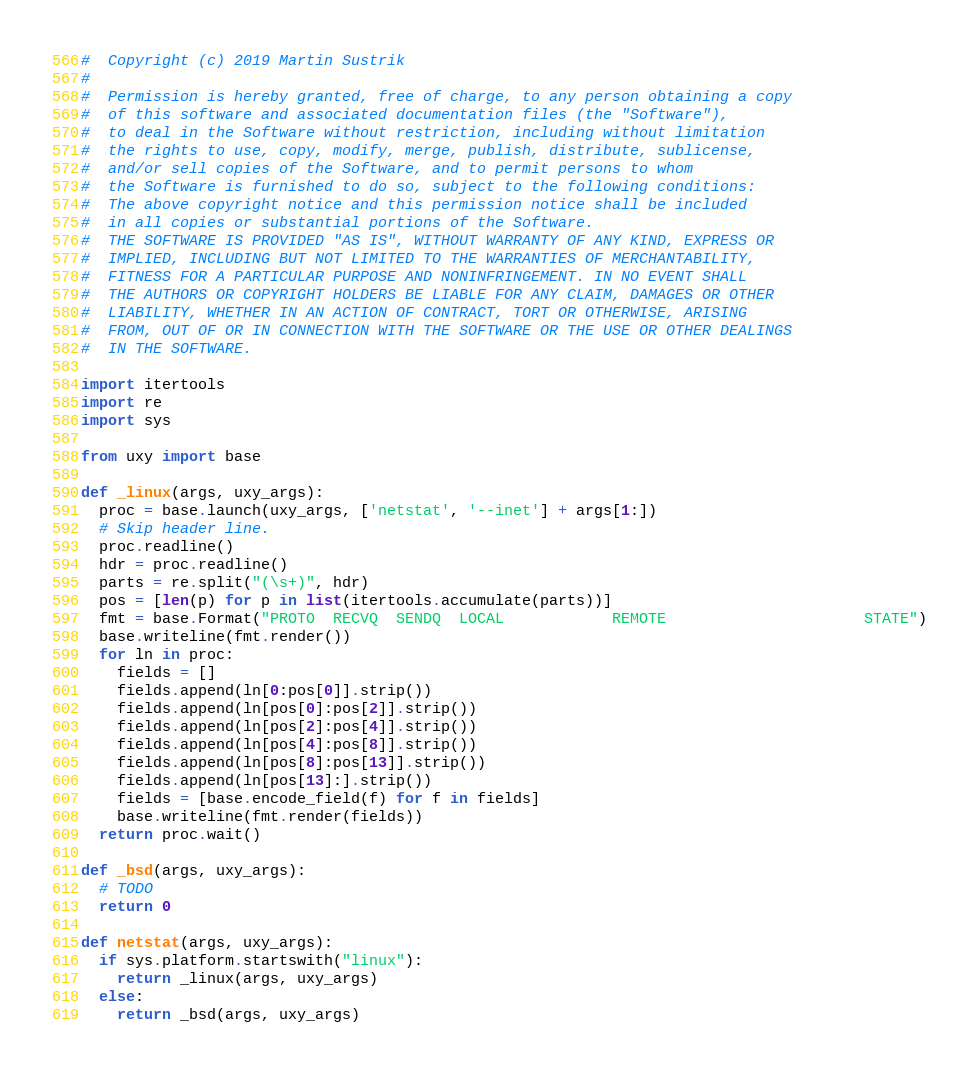<code> <loc_0><loc_0><loc_500><loc_500><_Python_>#  Copyright (c) 2019 Martin Sustrik
#
#  Permission is hereby granted, free of charge, to any person obtaining a copy
#  of this software and associated documentation files (the "Software"),
#  to deal in the Software without restriction, including without limitation
#  the rights to use, copy, modify, merge, publish, distribute, sublicense,
#  and/or sell copies of the Software, and to permit persons to whom
#  the Software is furnished to do so, subject to the following conditions:
#  The above copyright notice and this permission notice shall be included
#  in all copies or substantial portions of the Software.
#  THE SOFTWARE IS PROVIDED "AS IS", WITHOUT WARRANTY OF ANY KIND, EXPRESS OR
#  IMPLIED, INCLUDING BUT NOT LIMITED TO THE WARRANTIES OF MERCHANTABILITY,
#  FITNESS FOR A PARTICULAR PURPOSE AND NONINFRINGEMENT. IN NO EVENT SHALL
#  THE AUTHORS OR COPYRIGHT HOLDERS BE LIABLE FOR ANY CLAIM, DAMAGES OR OTHER
#  LIABILITY, WHETHER IN AN ACTION OF CONTRACT, TORT OR OTHERWISE, ARISING
#  FROM, OUT OF OR IN CONNECTION WITH THE SOFTWARE OR THE USE OR OTHER DEALINGS
#  IN THE SOFTWARE.

import itertools
import re
import sys

from uxy import base

def _linux(args, uxy_args):
  proc = base.launch(uxy_args, ['netstat', '--inet'] + args[1:])
  # Skip header line.
  proc.readline()
  hdr = proc.readline()
  parts = re.split("(\s+)", hdr)
  pos = [len(p) for p in list(itertools.accumulate(parts))]
  fmt = base.Format("PROTO  RECVQ  SENDQ  LOCAL            REMOTE                      STATE")
  base.writeline(fmt.render())
  for ln in proc:
    fields = []
    fields.append(ln[0:pos[0]].strip())
    fields.append(ln[pos[0]:pos[2]].strip())
    fields.append(ln[pos[2]:pos[4]].strip())
    fields.append(ln[pos[4]:pos[8]].strip())
    fields.append(ln[pos[8]:pos[13]].strip())
    fields.append(ln[pos[13]:].strip())
    fields = [base.encode_field(f) for f in fields]
    base.writeline(fmt.render(fields))
  return proc.wait()

def _bsd(args, uxy_args):
  # TODO
  return 0

def netstat(args, uxy_args):
  if sys.platform.startswith("linux"):
    return _linux(args, uxy_args)
  else:
    return _bsd(args, uxy_args)
</code> 